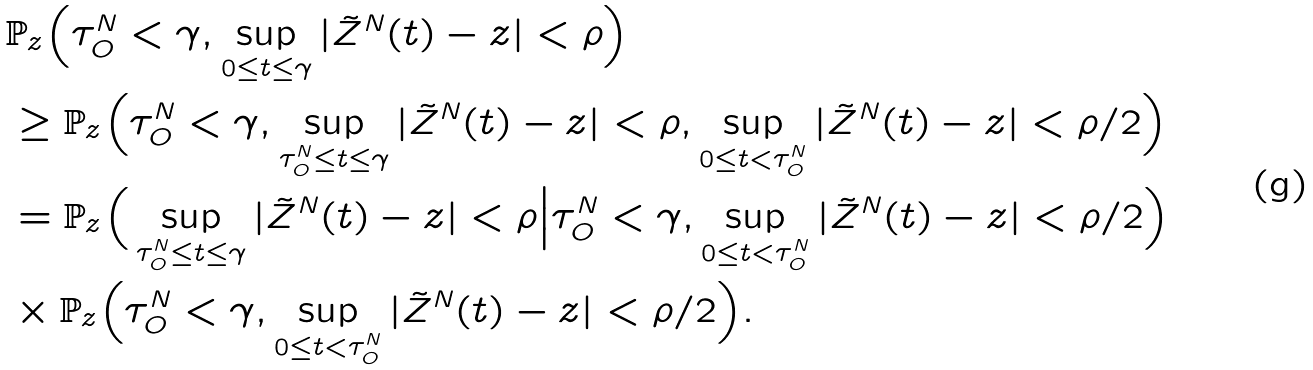Convert formula to latex. <formula><loc_0><loc_0><loc_500><loc_500>& \mathbb { P } _ { z } \Big ( \tau ^ { N } _ { O } < \gamma , \sup _ { 0 \leq t \leq \gamma } | \tilde { Z } ^ { N } ( t ) - z | < \rho \Big ) \\ & \geq \mathbb { P } _ { z } \Big ( \tau ^ { N } _ { O } < \gamma , \sup _ { \tau ^ { N } _ { O } \leq t \leq \gamma } | \tilde { Z } ^ { N } ( t ) - z | < \rho , \sup _ { 0 \leq t < \tau ^ { N } _ { O } } | \tilde { Z } ^ { N } ( t ) - z | < \rho / 2 \Big ) \\ & = \mathbb { P } _ { z } \Big ( \sup _ { \tau ^ { N } _ { O } \leq t \leq \gamma } | \tilde { Z } ^ { N } ( t ) - z | < \rho \Big | \tau ^ { N } _ { O } < \gamma , \sup _ { 0 \leq t < \tau ^ { N } _ { O } } | \tilde { Z } ^ { N } ( t ) - z | < \rho / 2 \Big ) \\ & \times \mathbb { P } _ { z } \Big ( \tau ^ { N } _ { O } < \gamma , \sup _ { 0 \leq t < \tau ^ { N } _ { O } } | \tilde { Z } ^ { N } ( t ) - z | < \rho / 2 \Big ) .</formula> 